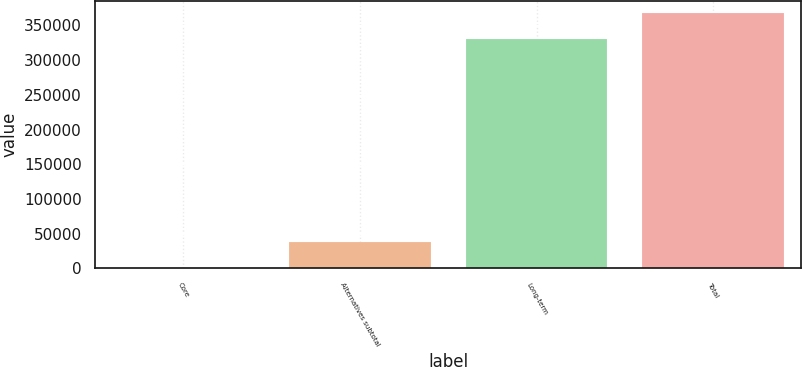<chart> <loc_0><loc_0><loc_500><loc_500><bar_chart><fcel>Core<fcel>Alternatives subtotal<fcel>Long-term<fcel>Total<nl><fcel>780<fcel>37427.4<fcel>330240<fcel>367254<nl></chart> 